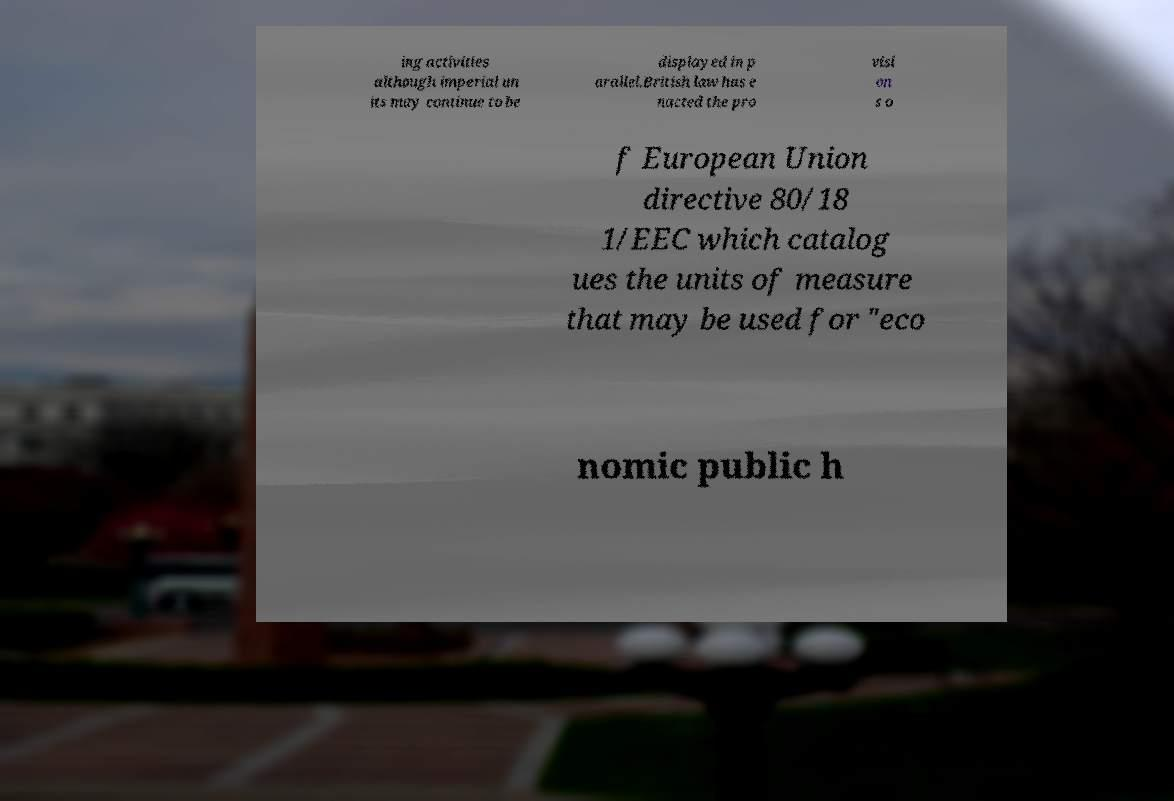Could you extract and type out the text from this image? ing activities although imperial un its may continue to be displayed in p arallel.British law has e nacted the pro visi on s o f European Union directive 80/18 1/EEC which catalog ues the units of measure that may be used for "eco nomic public h 